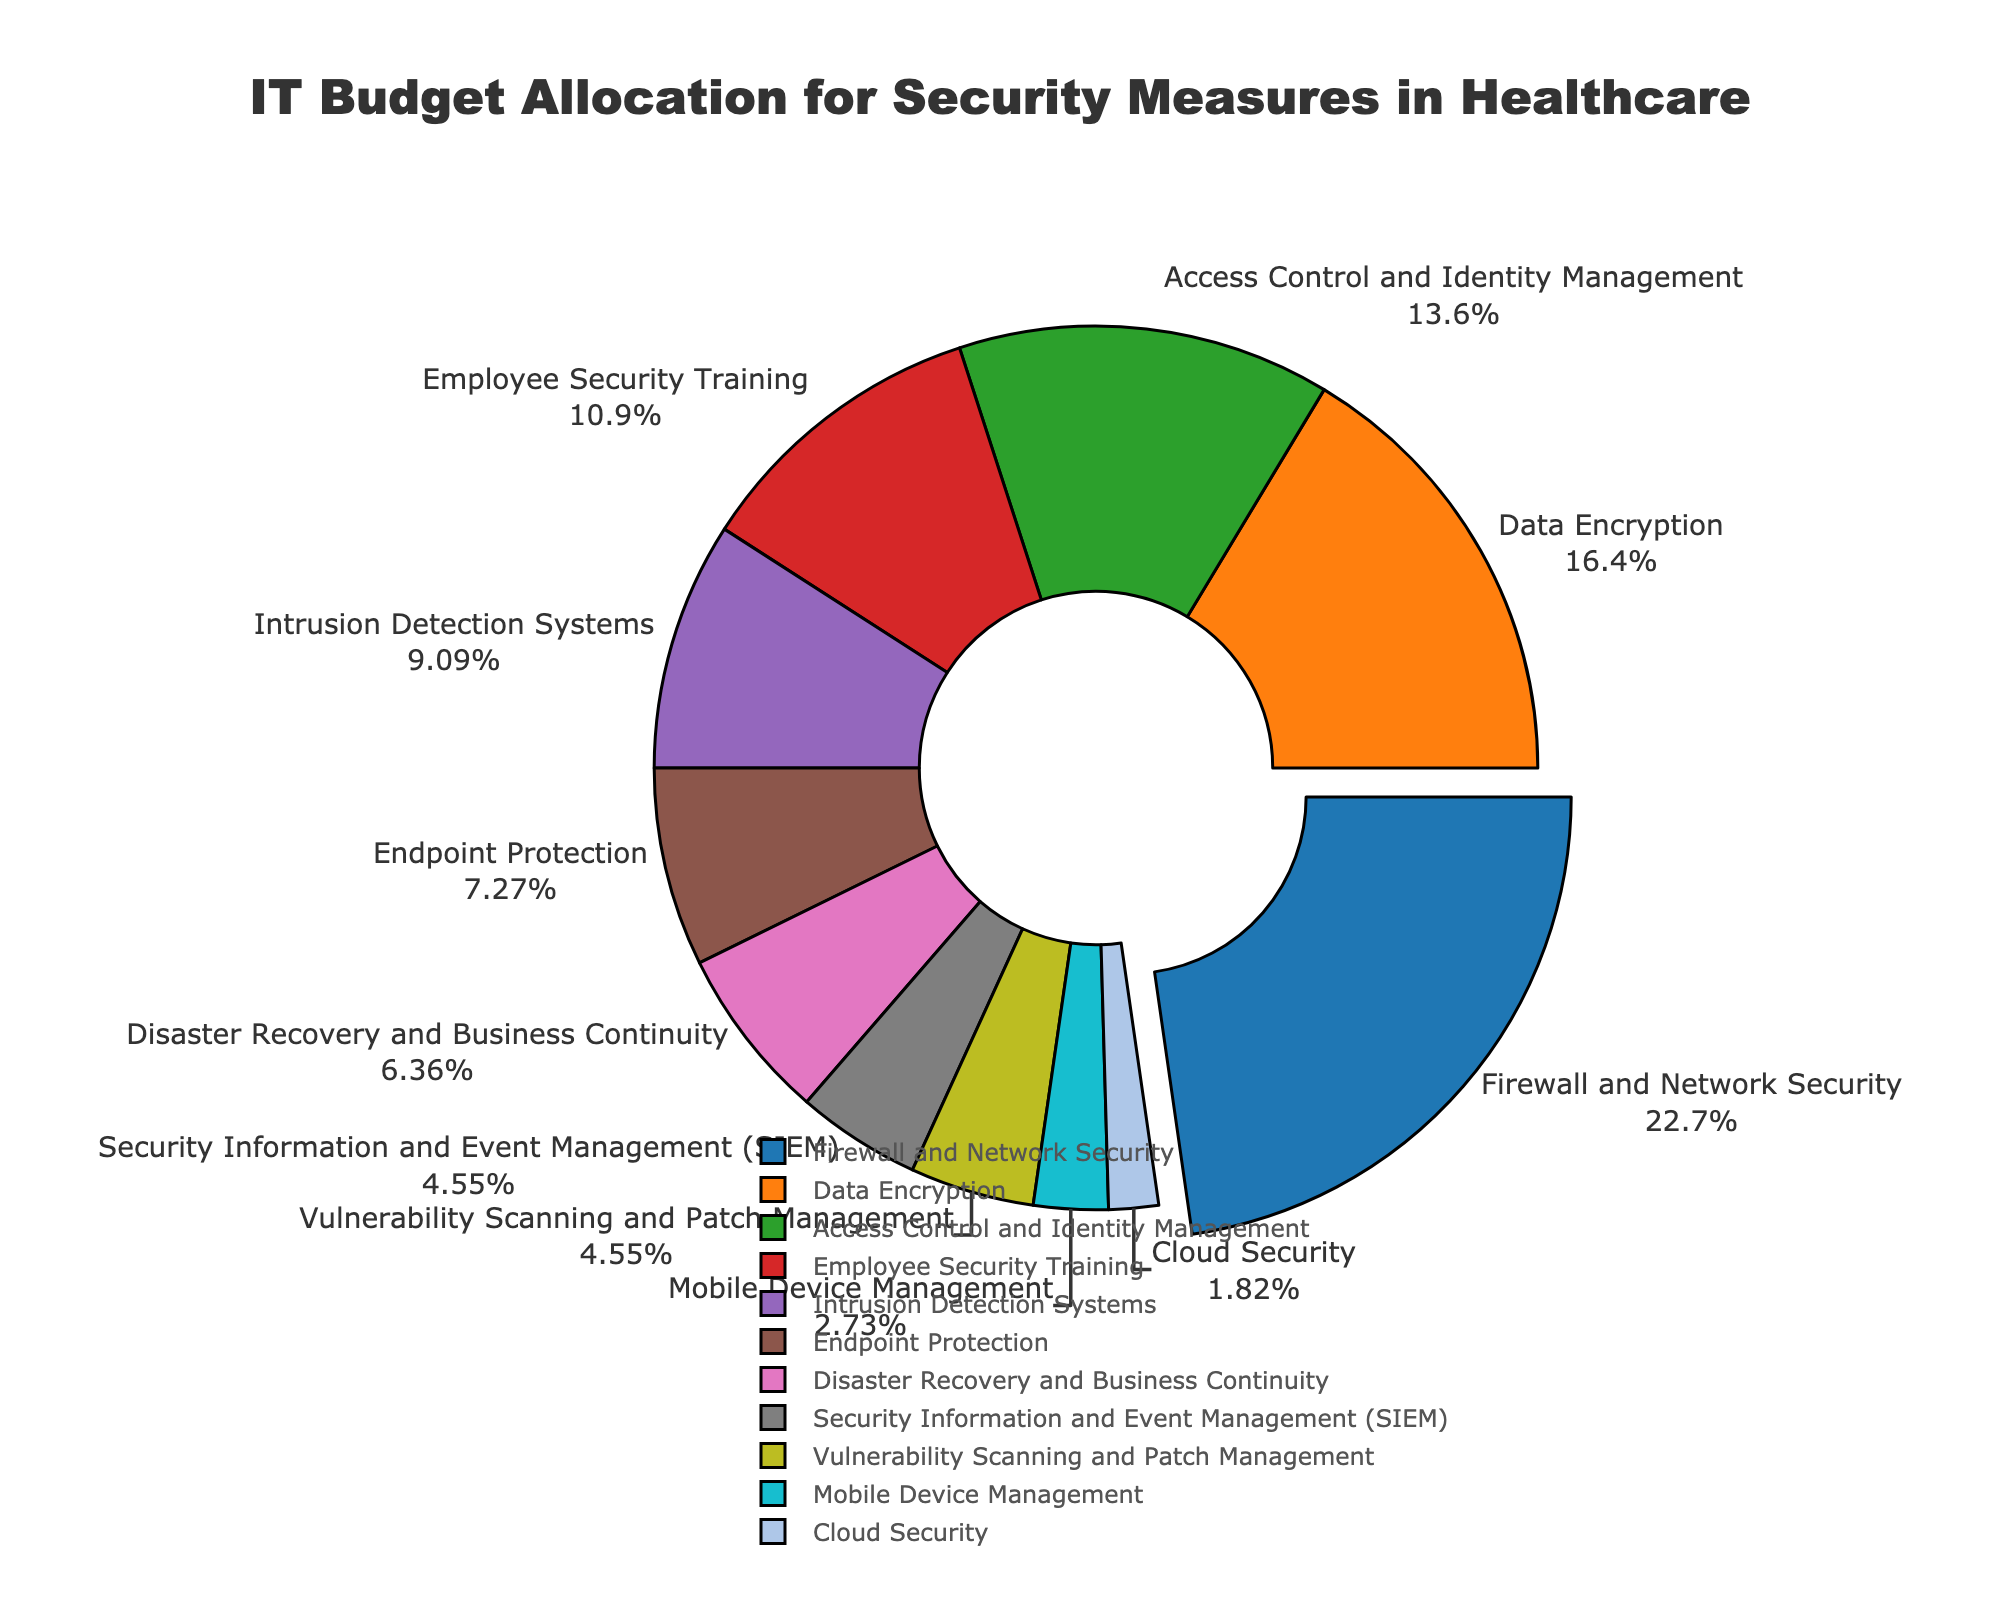What is the highest percentage of budget allocation and which security measure does it belong to? The segment with the largest pull from the pie chart represents the highest percentage. Looking at the text labels, Firewall and Network Security has the highest allocation at 25%.
Answer: 25%, Firewall and Network Security What is the combined budget allocation percentage for Data Encryption and Access Control and Identity Management? Add the percentages for Data Encryption (18%) and Access Control and Identity Management (15%). This totals 18 + 15 = 33%.
Answer: 33% How does the budget allocation for Employee Security Training compare to Endpoint Protection? Employee Security Training is allocated 12%, whereas Endpoint Protection is allocated 8%. Thus, Employee Security Training has a higher allocation by 4%.
Answer: Employee Security Training has 4% more Which security measure has the smallest budget allocation and what is its percentage? The smallest segment in the pie chart represents the lowest budget allocation. According to the labels, Cloud Security has the smallest allocation at 2%.
Answer: Cloud Security, 2% What is the total budget allocation percentage for all measures related to monitoring and response (SIEM and Intrusion Detection Systems)? Sum the percentages for Security Information and Event Management (SIEM) and Intrusion Detection Systems: 5% + 10% = 15%.
Answer: 15% What is the budget gap between Firewall and Network Security and Disaster Recovery and Business Continuity? Calculate the difference between their percentages: 25% (Firewall and Network Security) - 7% (Disaster Recovery and Business Continuity) = 18%.
Answer: 18% If you were to allocate an additional 10% of the budget to Endpoint Protection, what would its new percentage be? Add 10% to the existing allocation for Endpoint Protection: 8% + 10% = 18%.
Answer: 18% What is the average budget allocation percentage for all the security measures? Sum all the percentages (25 + 18 + 15 + 12 + 10 + 8 + 7 + 5 + 5 + 3 + 2 = 110) and divide by the number of measures (11). The average is 110/11 = 10%.
Answer: 10% 